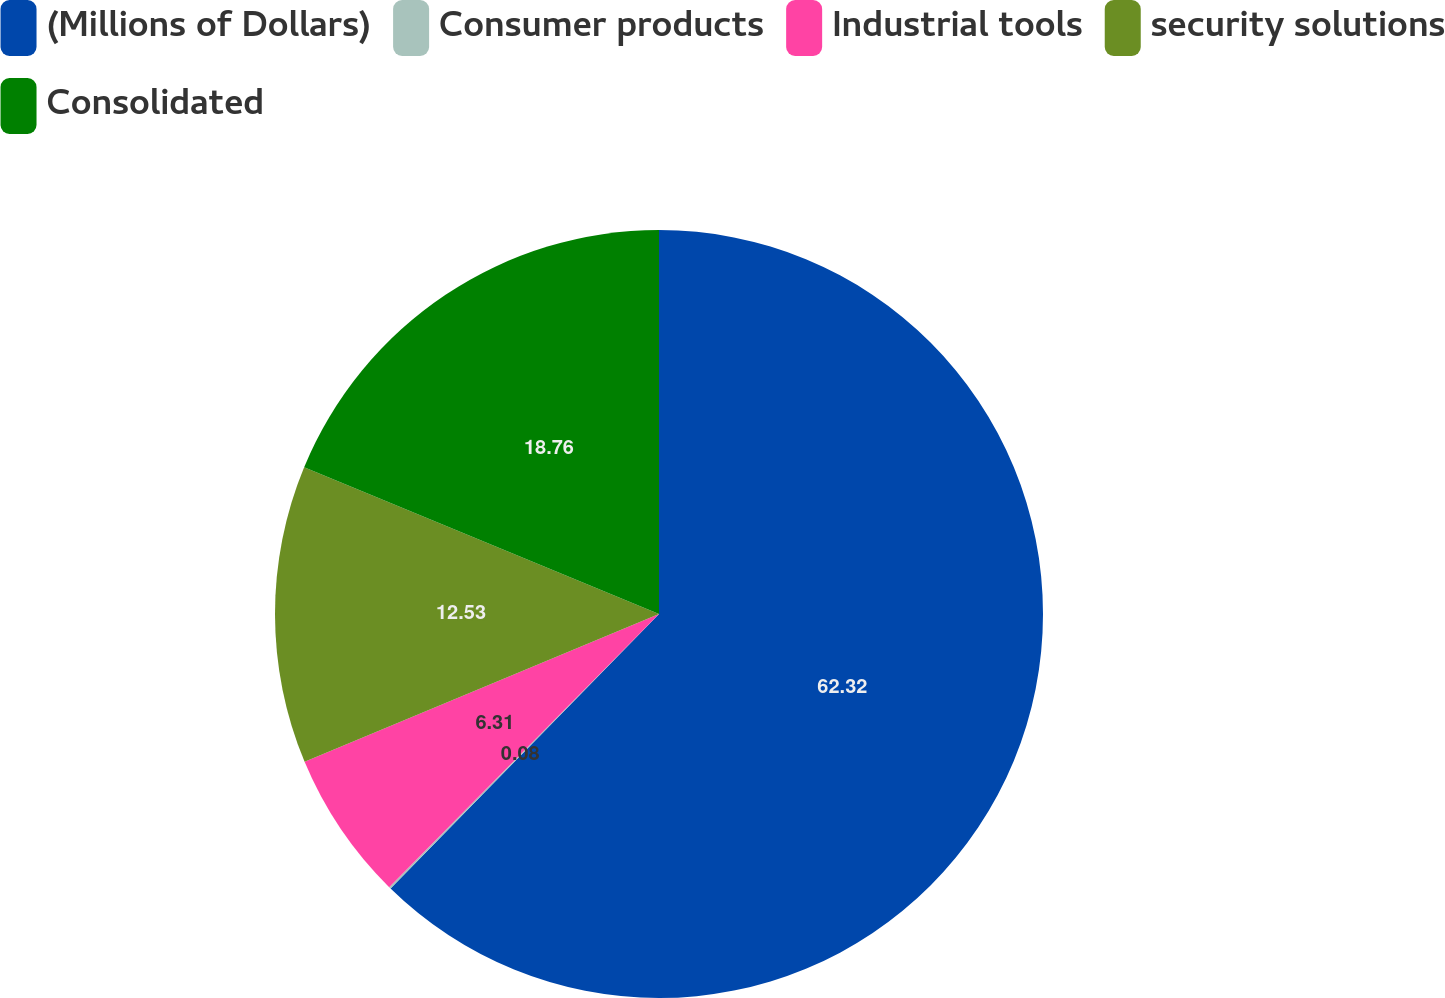Convert chart to OTSL. <chart><loc_0><loc_0><loc_500><loc_500><pie_chart><fcel>(Millions of Dollars)<fcel>Consumer products<fcel>Industrial tools<fcel>security solutions<fcel>Consolidated<nl><fcel>62.32%<fcel>0.08%<fcel>6.31%<fcel>12.53%<fcel>18.76%<nl></chart> 